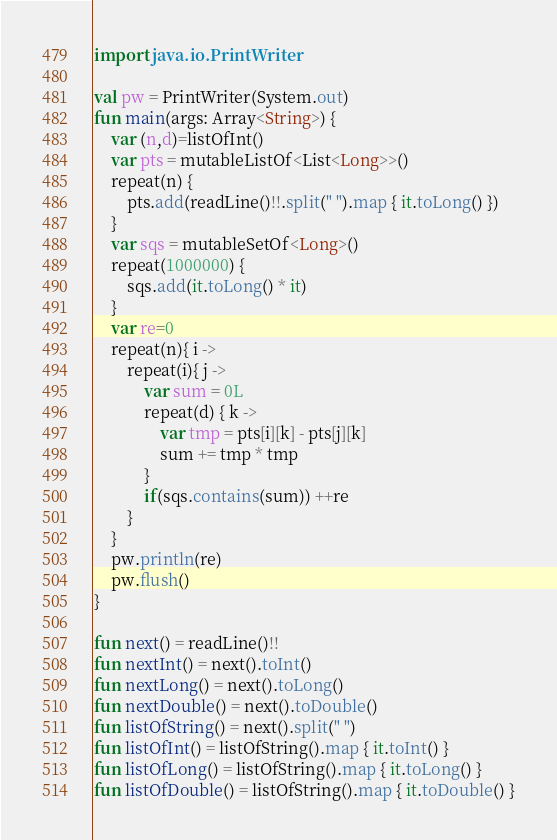<code> <loc_0><loc_0><loc_500><loc_500><_Kotlin_>import java.io.PrintWriter

val pw = PrintWriter(System.out)
fun main(args: Array<String>) {
    var (n,d)=listOfInt()
    var pts = mutableListOf<List<Long>>()
    repeat(n) {
        pts.add(readLine()!!.split(" ").map { it.toLong() })
    }
    var sqs = mutableSetOf<Long>()
    repeat(1000000) {
        sqs.add(it.toLong() * it)
    }
    var re=0
    repeat(n){ i ->
        repeat(i){ j ->
            var sum = 0L
            repeat(d) { k ->
                var tmp = pts[i][k] - pts[j][k]
                sum += tmp * tmp
            }
            if(sqs.contains(sum)) ++re
        }
    }
    pw.println(re)
    pw.flush()
}

fun next() = readLine()!!
fun nextInt() = next().toInt()
fun nextLong() = next().toLong()
fun nextDouble() = next().toDouble()
fun listOfString() = next().split(" ")
fun listOfInt() = listOfString().map { it.toInt() }
fun listOfLong() = listOfString().map { it.toLong() }
fun listOfDouble() = listOfString().map { it.toDouble() }
</code> 